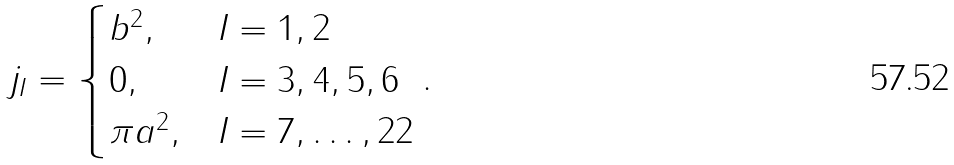Convert formula to latex. <formula><loc_0><loc_0><loc_500><loc_500>j _ { I } = \begin{cases} b ^ { 2 } , & I = 1 , 2 \\ 0 , & I = 3 , 4 , 5 , 6 \\ \pi a ^ { 2 } , & I = 7 , \dots , 2 2 \end{cases} .</formula> 